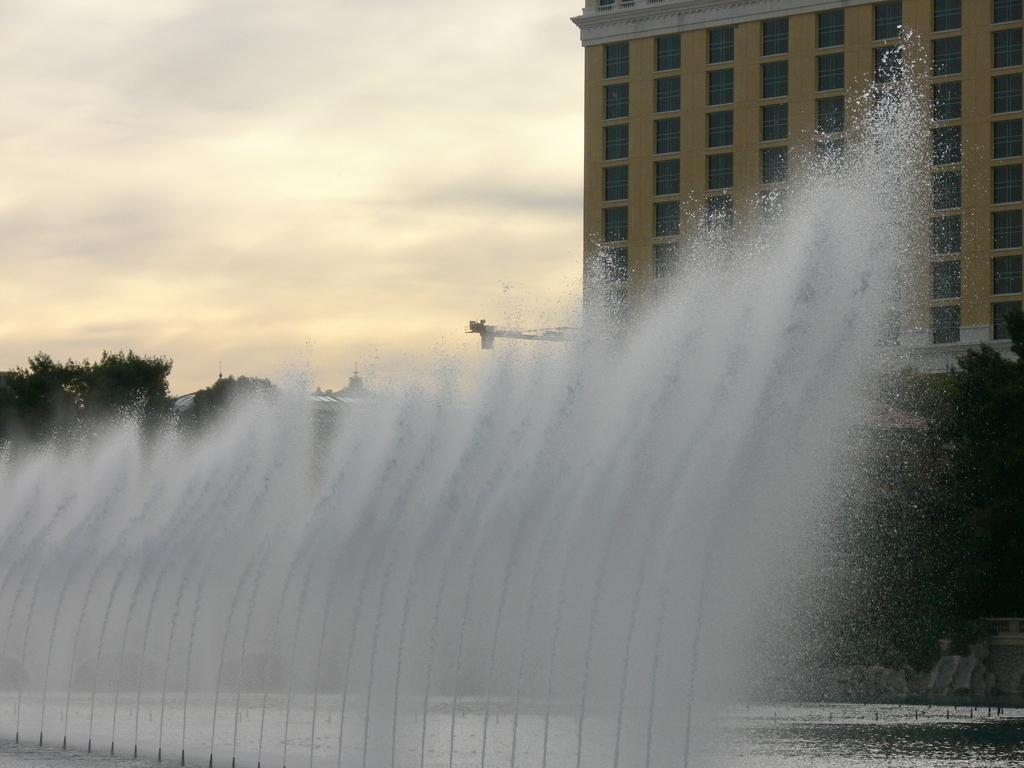What type of structure is present in the image? There is a building in the image. What other natural elements can be seen in the image? There are trees in the image. Are there any water features in the image? Yes, there is a water fountain in the image. How would you describe the weather in the image? The sky is cloudy in the image. Can you tell me how many brains are visible in the image? There are no brains present in the image. What type of play is happening in the image? There is no play or any indication of a play in the image. 